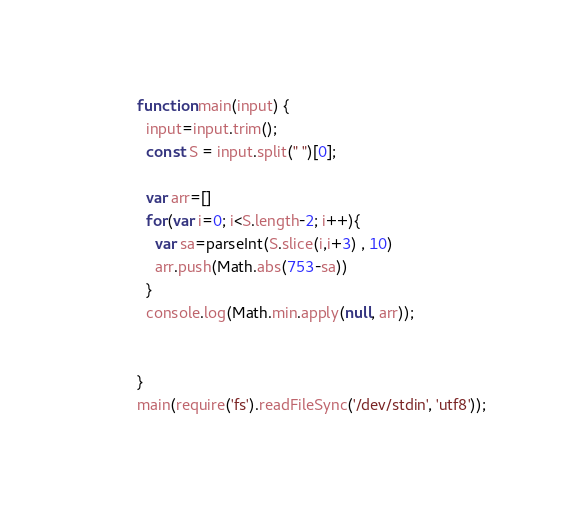Convert code to text. <code><loc_0><loc_0><loc_500><loc_500><_JavaScript_>function main(input) {
  input=input.trim();
  const S = input.split(" ")[0];

  var arr=[]
  for(var i=0; i<S.length-2; i++){
    var sa=parseInt(S.slice(i,i+3) , 10)
    arr.push(Math.abs(753-sa))
  }
  console.log(Math.min.apply(null, arr));
  

}
main(require('fs').readFileSync('/dev/stdin', 'utf8'));</code> 